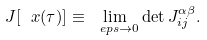<formula> <loc_0><loc_0><loc_500><loc_500>J [ \ x ( \tau ) ] \equiv \lim _ { \ e p s \rightarrow 0 } \det J ^ { \alpha \beta } _ { i j } .</formula> 